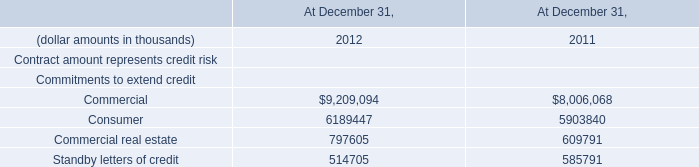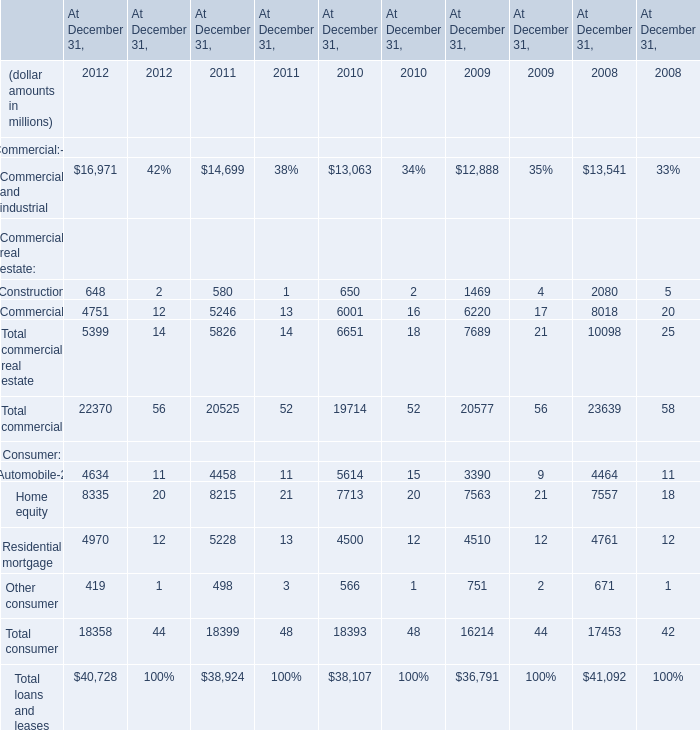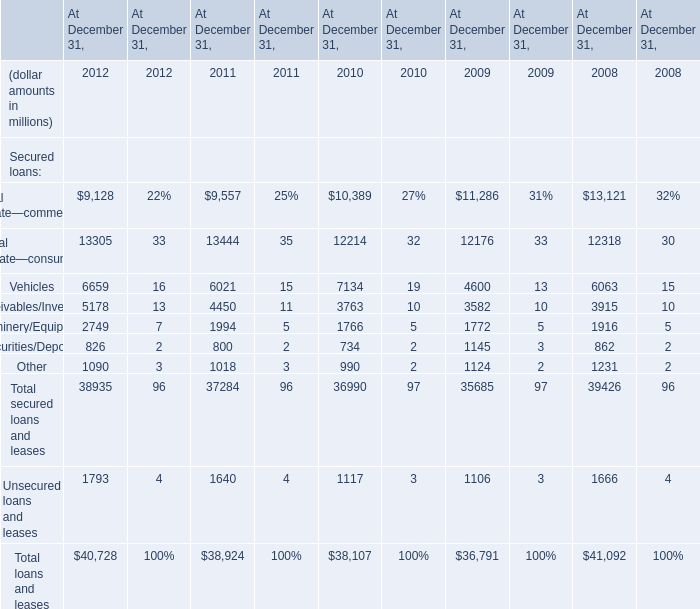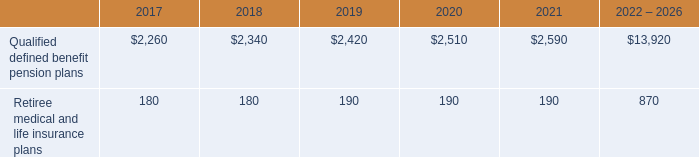What's the total value of all Secured loans that are in the range of 0 and 2000 in 2012? (in million) 
Computations: ((826 + 1090) + 1793)
Answer: 3709.0. 